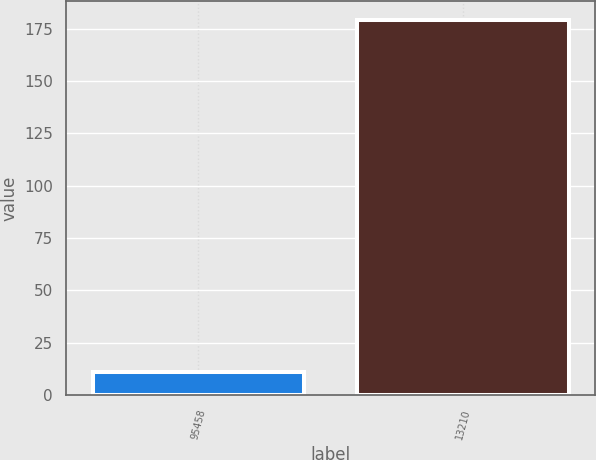<chart> <loc_0><loc_0><loc_500><loc_500><bar_chart><fcel>95458<fcel>13210<nl><fcel>11<fcel>179<nl></chart> 